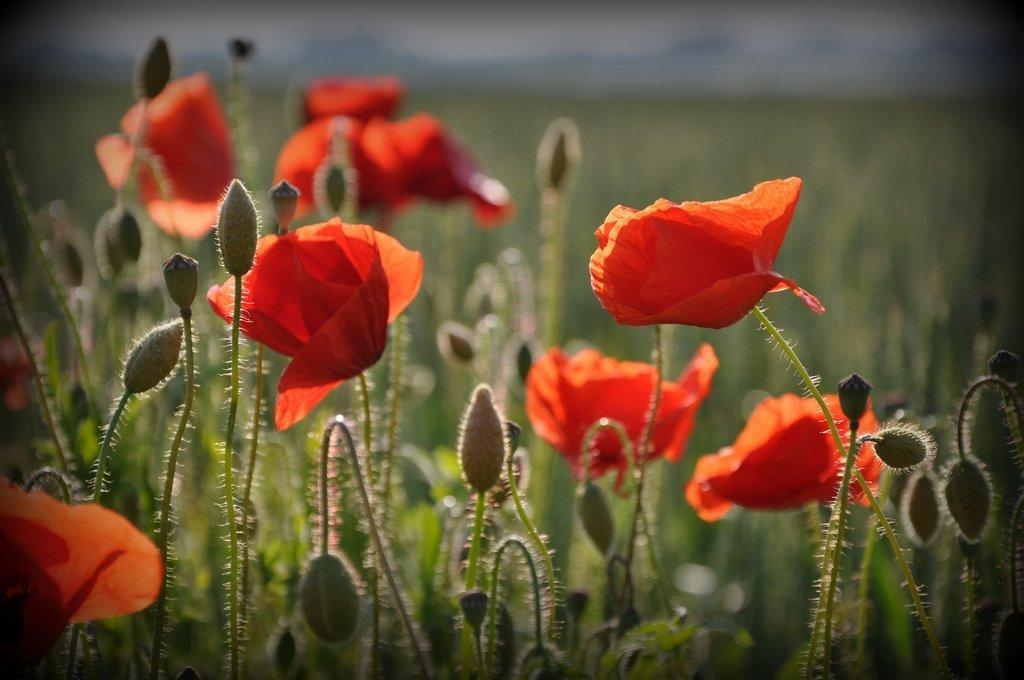What is the main subject in the center of the image? There are plants and flowers in the center of the image. What color are the plants and flowers? The plants and flowers are in orange color. What type of bath can be seen in the image? There is no bath present in the image; it features plants and flowers in orange color. What type of writing instrument is being used by the writer in the image? There is no writer or writing instrument present in the image. 